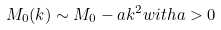<formula> <loc_0><loc_0><loc_500><loc_500>M _ { 0 } ( k ) \sim M _ { 0 } - a k ^ { 2 } w i t h a > 0</formula> 